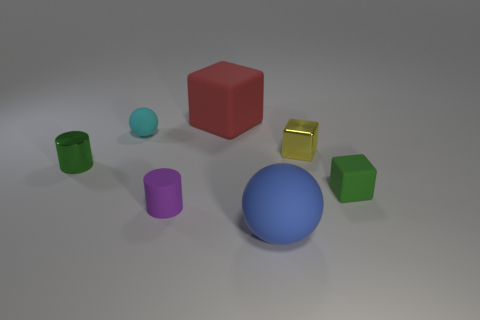Add 2 blue metal balls. How many objects exist? 9 Subtract all balls. How many objects are left? 5 Add 2 yellow spheres. How many yellow spheres exist? 2 Subtract 1 yellow blocks. How many objects are left? 6 Subtract all blue matte balls. Subtract all tiny blocks. How many objects are left? 4 Add 3 small cubes. How many small cubes are left? 5 